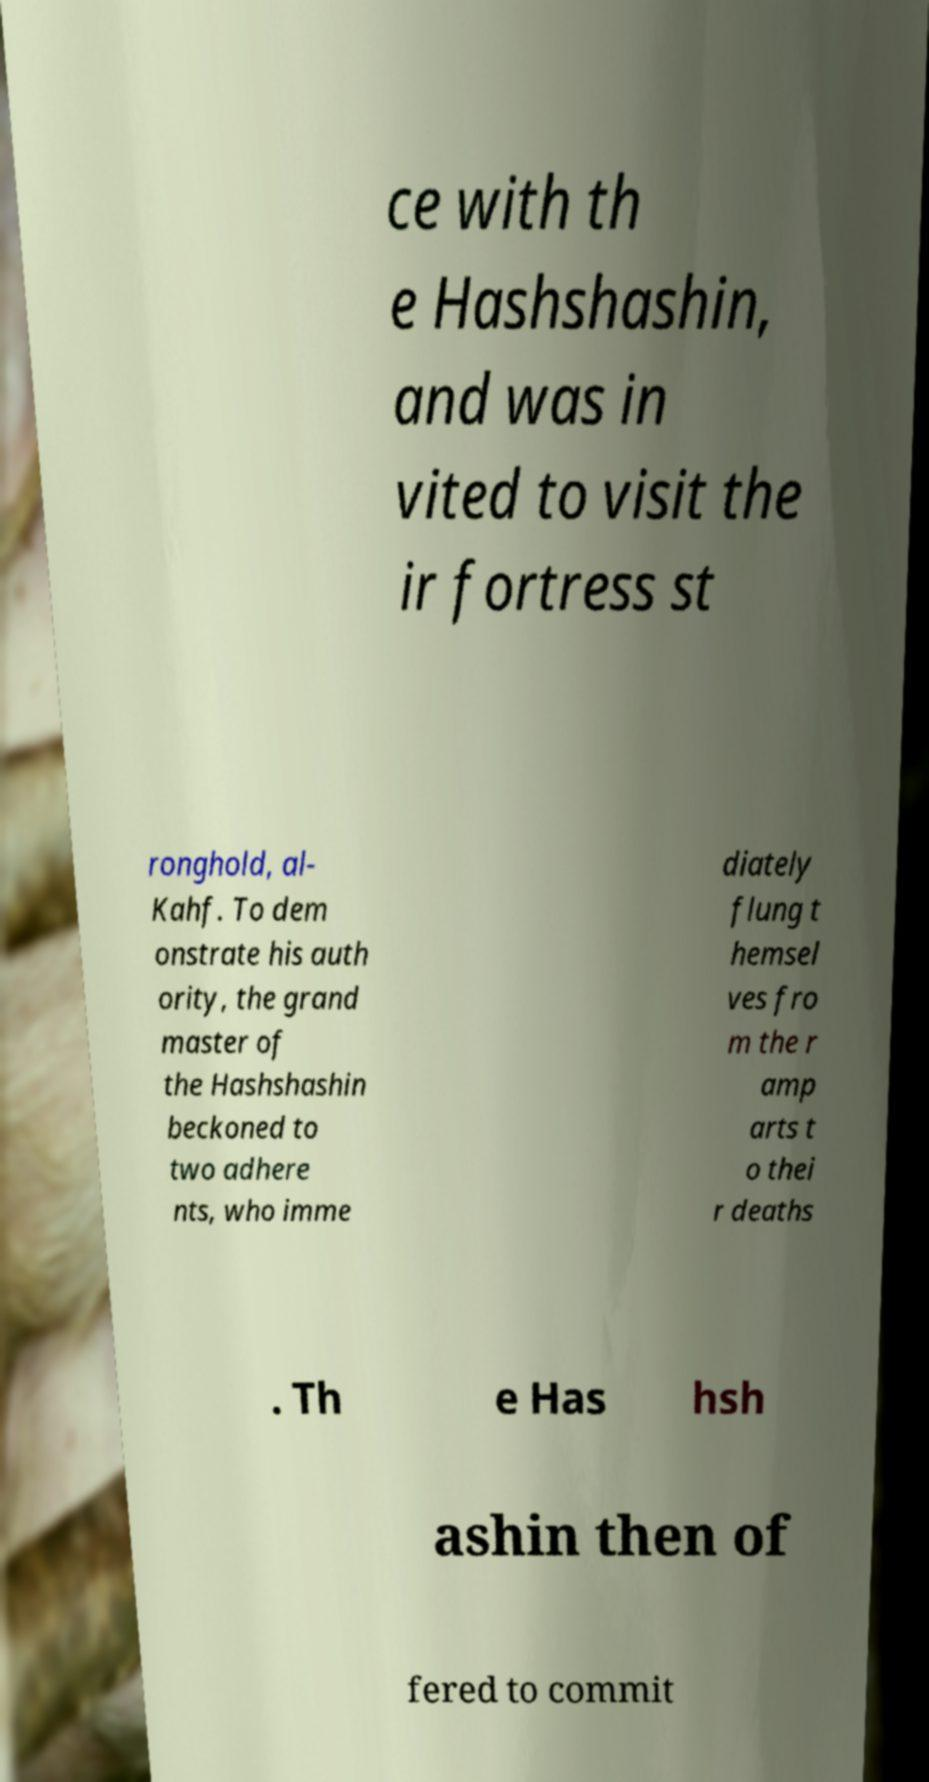Can you read and provide the text displayed in the image?This photo seems to have some interesting text. Can you extract and type it out for me? ce with th e Hashshashin, and was in vited to visit the ir fortress st ronghold, al- Kahf. To dem onstrate his auth ority, the grand master of the Hashshashin beckoned to two adhere nts, who imme diately flung t hemsel ves fro m the r amp arts t o thei r deaths . Th e Has hsh ashin then of fered to commit 